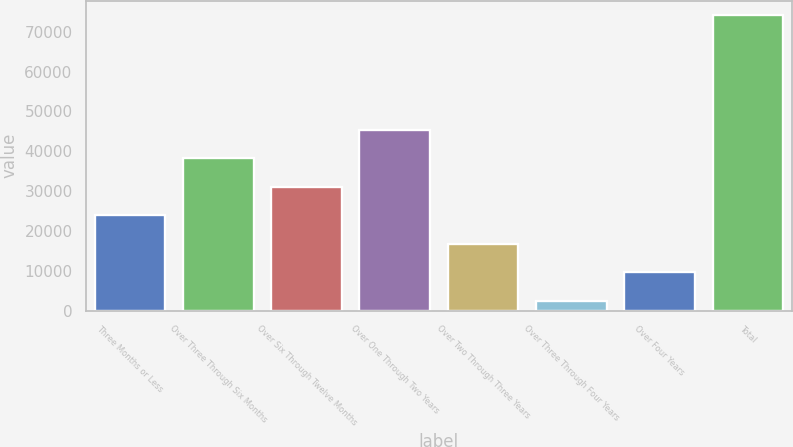Convert chart to OTSL. <chart><loc_0><loc_0><loc_500><loc_500><bar_chart><fcel>Three Months or Less<fcel>Over Three Through Six Months<fcel>Over Six Through Twelve Months<fcel>Over One Through Two Years<fcel>Over Two Through Three Years<fcel>Over Three Through Four Years<fcel>Over Four Years<fcel>Total<nl><fcel>23931.6<fcel>38258<fcel>31094.8<fcel>45421.2<fcel>16768.4<fcel>2442<fcel>9605.2<fcel>74074<nl></chart> 